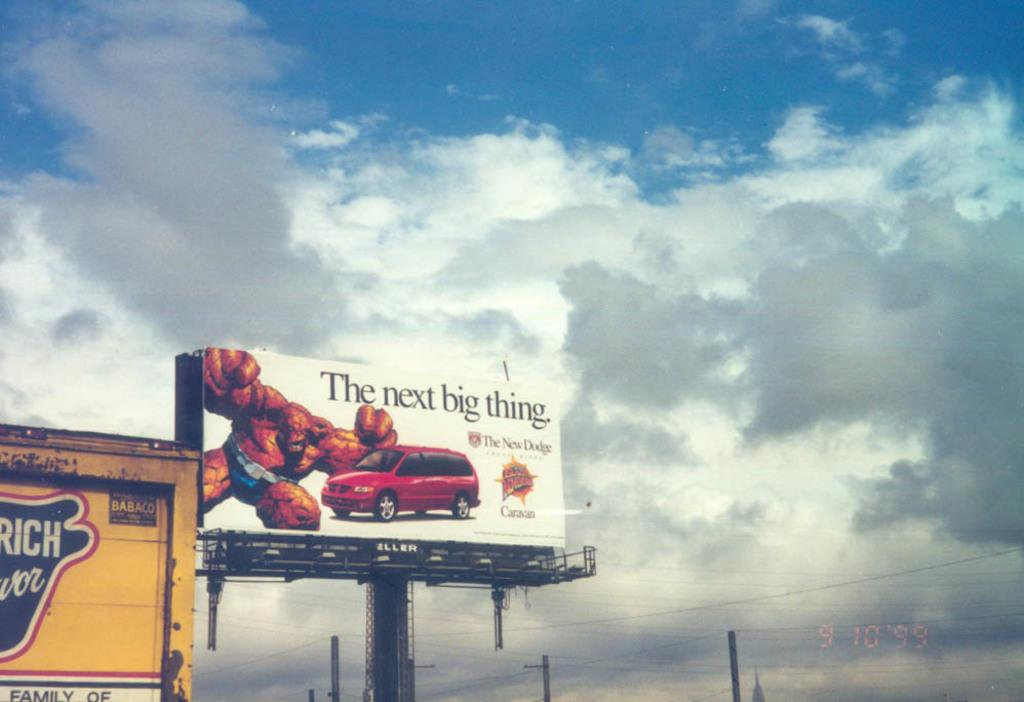<image>
Offer a succinct explanation of the picture presented. Billboard beside a building that says the next big thing 